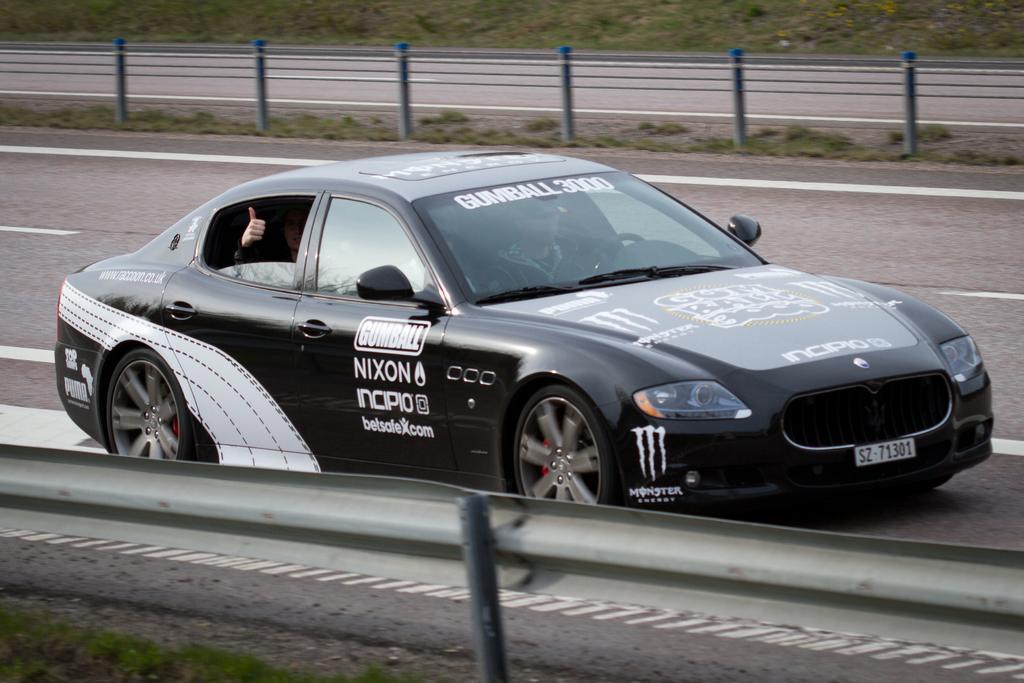How would you summarize this image in a sentence or two? In this image I can see a road and on it I can see a black colour car. I can also see few people inside this car and on this car I can see something is written. In the background I can see railing and grass. 